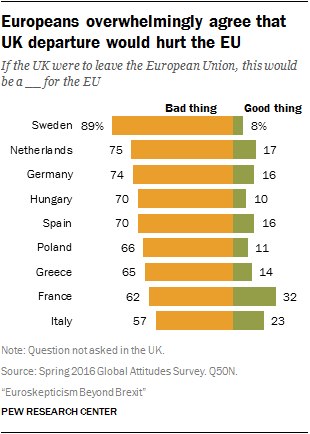Indicate a few pertinent items in this graphic. The value of the smallest green bar is 8, and it is true. Of the orange bars, two have a value that equals 70. 